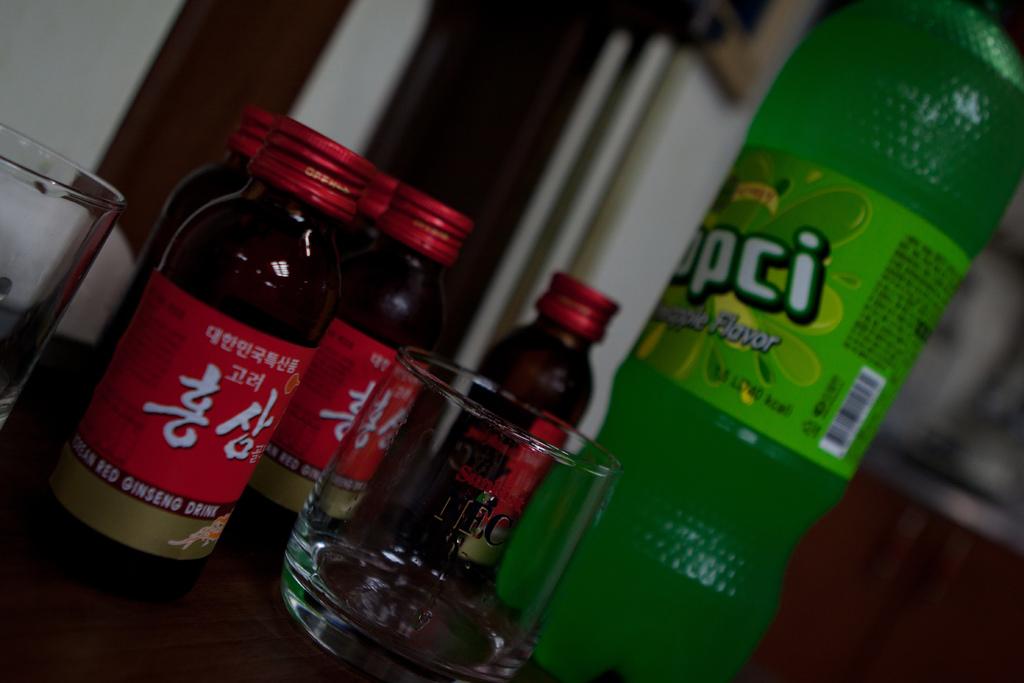What is the last letter of the brand on the green bottle/?
Provide a succinct answer. I. 